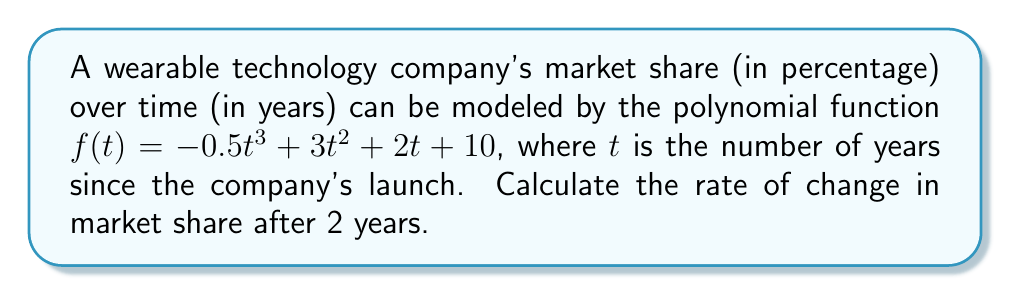What is the answer to this math problem? To find the rate of change in market share, we need to differentiate the given polynomial function and evaluate it at $t = 2$. Let's follow these steps:

1. The original function is:
   $f(t) = -0.5t^3 + 3t^2 + 2t + 10$

2. To find the rate of change, we need to find $f'(t)$:
   $f'(t) = \frac{d}{dt}(-0.5t^3 + 3t^2 + 2t + 10)$

3. Applying the power rule of differentiation:
   $f'(t) = -0.5 \cdot 3t^2 + 3 \cdot 2t + 2 + 0$
   $f'(t) = -1.5t^2 + 6t + 2$

4. Now, we need to evaluate $f'(2)$:
   $f'(2) = -1.5(2)^2 + 6(2) + 2$
   $f'(2) = -1.5 \cdot 4 + 12 + 2$
   $f'(2) = -6 + 12 + 2$
   $f'(2) = 8$

Therefore, the rate of change in market share after 2 years is 8 percentage points per year.
Answer: 8 percentage points per year 